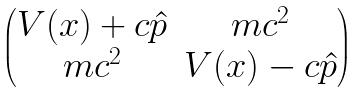Convert formula to latex. <formula><loc_0><loc_0><loc_500><loc_500>\begin{pmatrix} V ( x ) + c \hat { p } & m c ^ { 2 } \\ m c ^ { 2 } & V ( x ) - c \hat { p } \end{pmatrix}</formula> 